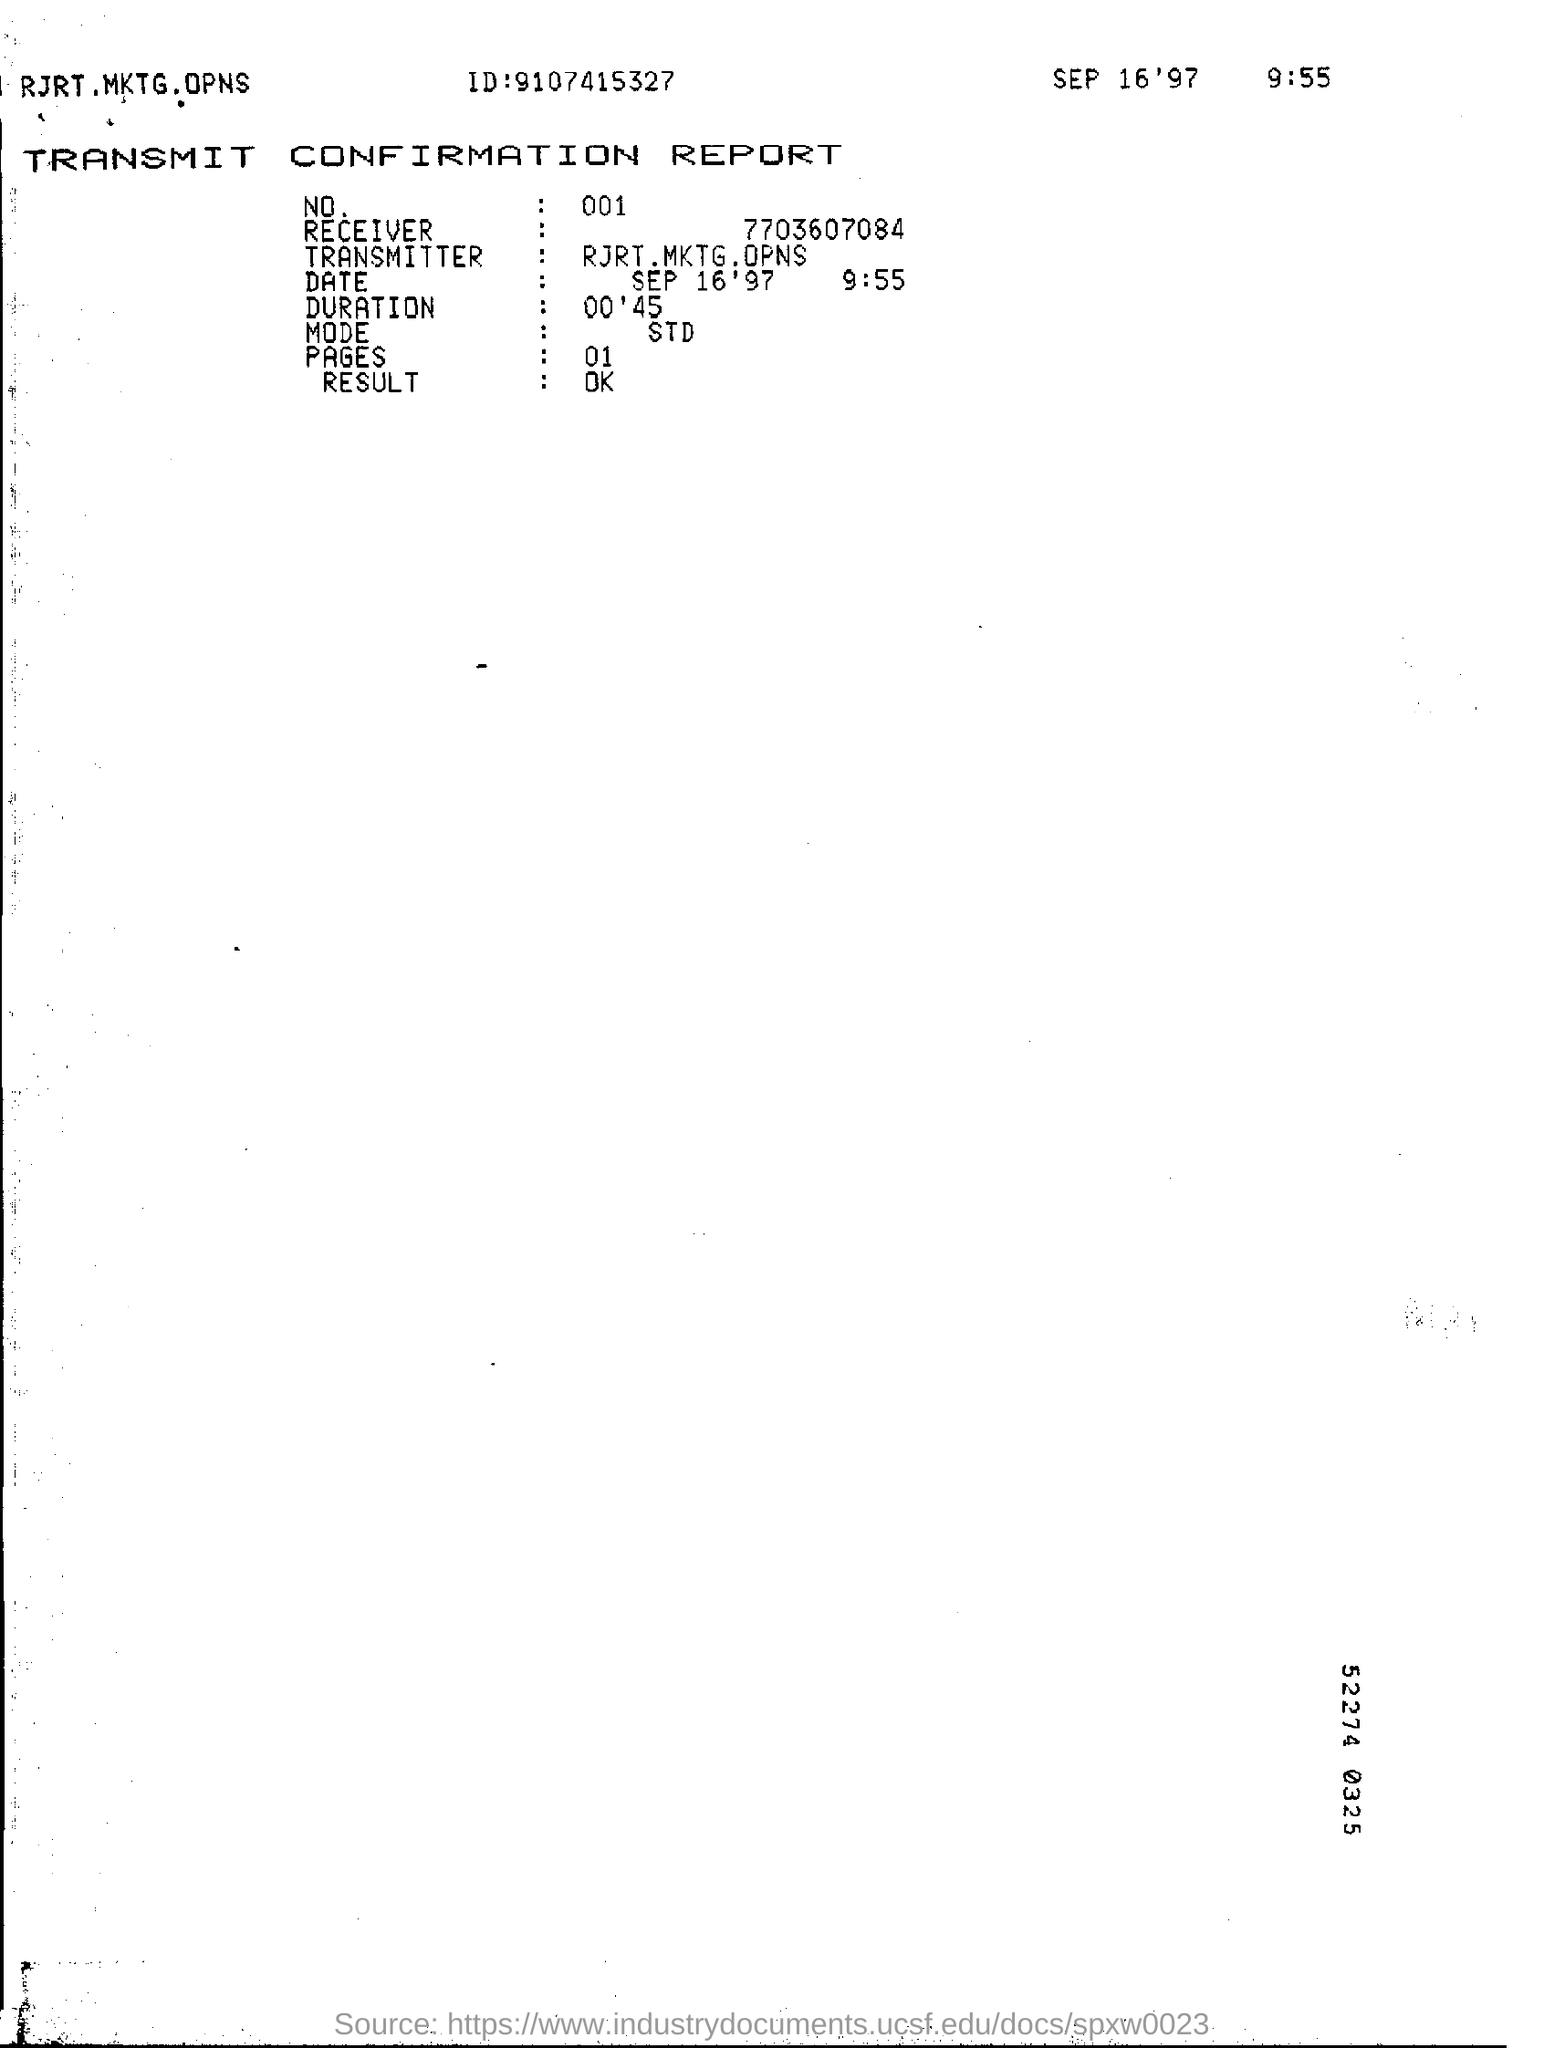Mention a couple of crucial points in this snapshot. The number of pages in the report is included. The duration mentioned on the report is 00'45. What is the mode of the report?" is a question asking for information. 